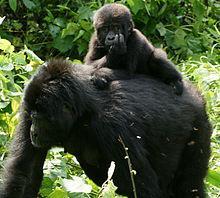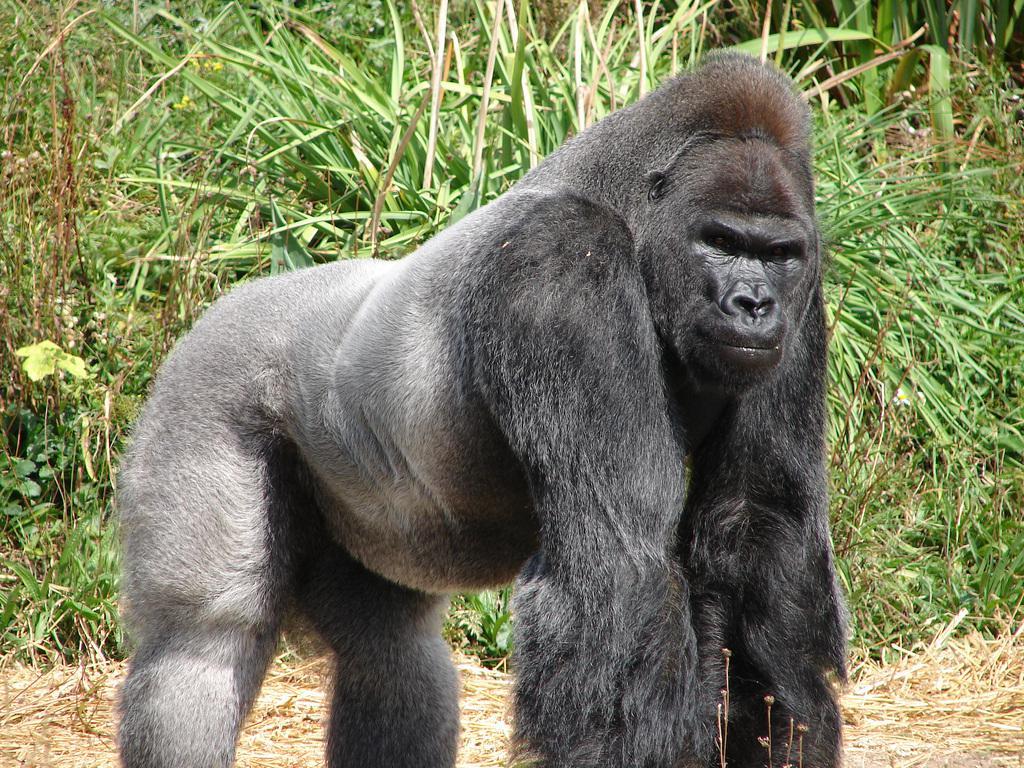The first image is the image on the left, the second image is the image on the right. Assess this claim about the two images: "A baby gorilla is being carried by its mother.". Correct or not? Answer yes or no. Yes. The first image is the image on the left, the second image is the image on the right. For the images displayed, is the sentence "An image includes a baby gorilla with at least one adult gorilla." factually correct? Answer yes or no. Yes. 